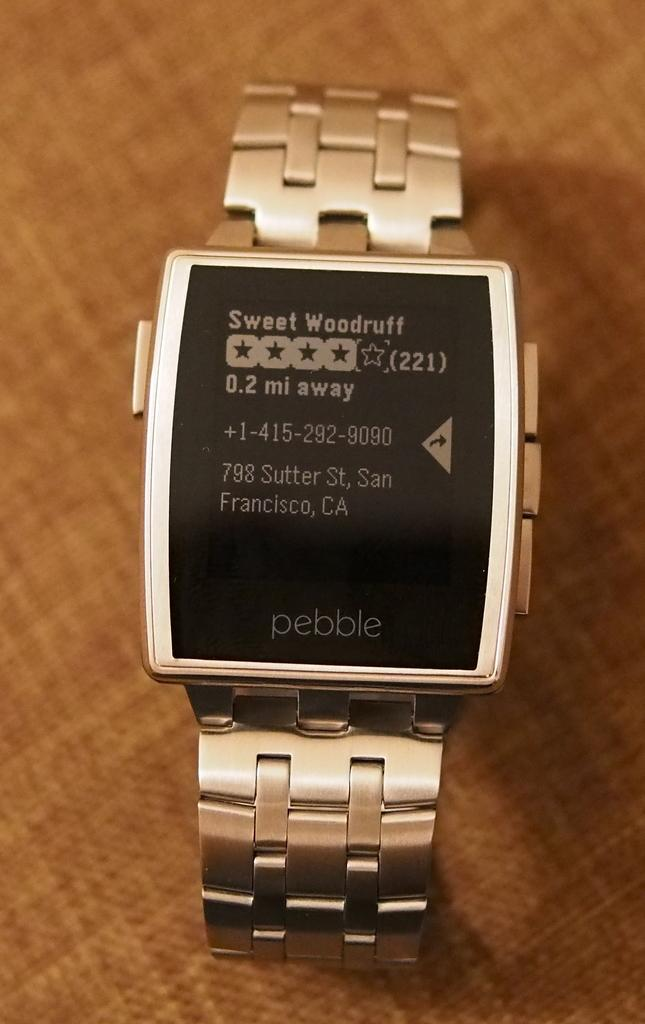<image>
Give a short and clear explanation of the subsequent image. A watch shows a review for Sweet Woodruff on its screen. 